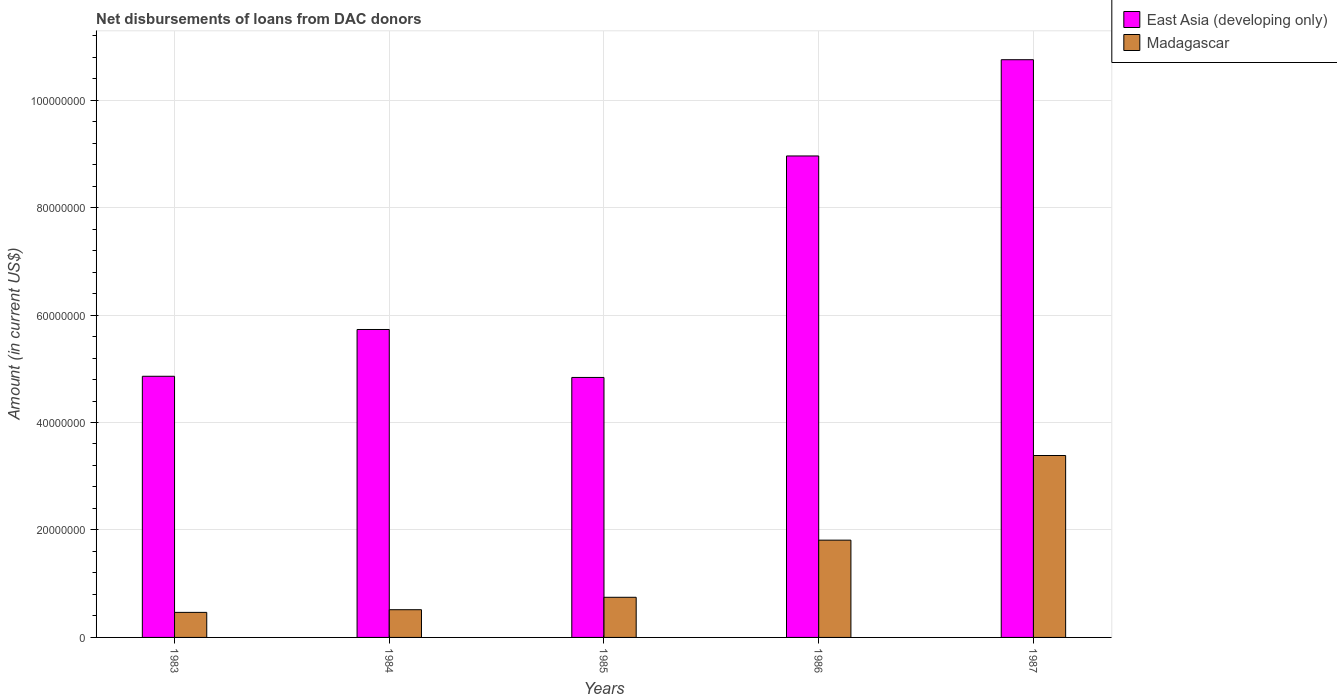How many groups of bars are there?
Provide a succinct answer. 5. Are the number of bars per tick equal to the number of legend labels?
Ensure brevity in your answer.  Yes. Are the number of bars on each tick of the X-axis equal?
Provide a succinct answer. Yes. What is the amount of loans disbursed in East Asia (developing only) in 1987?
Your answer should be very brief. 1.08e+08. Across all years, what is the maximum amount of loans disbursed in Madagascar?
Offer a very short reply. 3.39e+07. Across all years, what is the minimum amount of loans disbursed in East Asia (developing only)?
Your answer should be very brief. 4.84e+07. In which year was the amount of loans disbursed in East Asia (developing only) maximum?
Offer a terse response. 1987. What is the total amount of loans disbursed in Madagascar in the graph?
Your answer should be compact. 6.92e+07. What is the difference between the amount of loans disbursed in East Asia (developing only) in 1984 and that in 1985?
Give a very brief answer. 8.92e+06. What is the difference between the amount of loans disbursed in East Asia (developing only) in 1983 and the amount of loans disbursed in Madagascar in 1985?
Your answer should be very brief. 4.11e+07. What is the average amount of loans disbursed in Madagascar per year?
Offer a terse response. 1.38e+07. In the year 1986, what is the difference between the amount of loans disbursed in Madagascar and amount of loans disbursed in East Asia (developing only)?
Offer a very short reply. -7.15e+07. In how many years, is the amount of loans disbursed in East Asia (developing only) greater than 56000000 US$?
Keep it short and to the point. 3. What is the ratio of the amount of loans disbursed in Madagascar in 1983 to that in 1986?
Offer a terse response. 0.26. Is the amount of loans disbursed in Madagascar in 1983 less than that in 1986?
Your answer should be very brief. Yes. Is the difference between the amount of loans disbursed in Madagascar in 1983 and 1987 greater than the difference between the amount of loans disbursed in East Asia (developing only) in 1983 and 1987?
Make the answer very short. Yes. What is the difference between the highest and the second highest amount of loans disbursed in East Asia (developing only)?
Make the answer very short. 1.79e+07. What is the difference between the highest and the lowest amount of loans disbursed in East Asia (developing only)?
Your answer should be compact. 5.91e+07. What does the 2nd bar from the left in 1983 represents?
Offer a very short reply. Madagascar. What does the 1st bar from the right in 1987 represents?
Ensure brevity in your answer.  Madagascar. Does the graph contain any zero values?
Keep it short and to the point. No. Does the graph contain grids?
Give a very brief answer. Yes. How many legend labels are there?
Your response must be concise. 2. How are the legend labels stacked?
Offer a terse response. Vertical. What is the title of the graph?
Your response must be concise. Net disbursements of loans from DAC donors. What is the label or title of the X-axis?
Provide a short and direct response. Years. What is the label or title of the Y-axis?
Give a very brief answer. Amount (in current US$). What is the Amount (in current US$) in East Asia (developing only) in 1983?
Your answer should be very brief. 4.86e+07. What is the Amount (in current US$) of Madagascar in 1983?
Offer a very short reply. 4.66e+06. What is the Amount (in current US$) in East Asia (developing only) in 1984?
Your answer should be compact. 5.73e+07. What is the Amount (in current US$) in Madagascar in 1984?
Your answer should be very brief. 5.16e+06. What is the Amount (in current US$) in East Asia (developing only) in 1985?
Provide a succinct answer. 4.84e+07. What is the Amount (in current US$) in Madagascar in 1985?
Offer a very short reply. 7.47e+06. What is the Amount (in current US$) of East Asia (developing only) in 1986?
Your answer should be very brief. 8.96e+07. What is the Amount (in current US$) in Madagascar in 1986?
Give a very brief answer. 1.81e+07. What is the Amount (in current US$) of East Asia (developing only) in 1987?
Provide a short and direct response. 1.08e+08. What is the Amount (in current US$) of Madagascar in 1987?
Your answer should be very brief. 3.39e+07. Across all years, what is the maximum Amount (in current US$) of East Asia (developing only)?
Keep it short and to the point. 1.08e+08. Across all years, what is the maximum Amount (in current US$) of Madagascar?
Provide a succinct answer. 3.39e+07. Across all years, what is the minimum Amount (in current US$) of East Asia (developing only)?
Offer a terse response. 4.84e+07. Across all years, what is the minimum Amount (in current US$) in Madagascar?
Ensure brevity in your answer.  4.66e+06. What is the total Amount (in current US$) in East Asia (developing only) in the graph?
Make the answer very short. 3.51e+08. What is the total Amount (in current US$) of Madagascar in the graph?
Your answer should be very brief. 6.92e+07. What is the difference between the Amount (in current US$) in East Asia (developing only) in 1983 and that in 1984?
Ensure brevity in your answer.  -8.71e+06. What is the difference between the Amount (in current US$) in Madagascar in 1983 and that in 1984?
Give a very brief answer. -4.95e+05. What is the difference between the Amount (in current US$) of East Asia (developing only) in 1983 and that in 1985?
Ensure brevity in your answer.  2.18e+05. What is the difference between the Amount (in current US$) of Madagascar in 1983 and that in 1985?
Keep it short and to the point. -2.81e+06. What is the difference between the Amount (in current US$) in East Asia (developing only) in 1983 and that in 1986?
Offer a very short reply. -4.10e+07. What is the difference between the Amount (in current US$) of Madagascar in 1983 and that in 1986?
Ensure brevity in your answer.  -1.34e+07. What is the difference between the Amount (in current US$) in East Asia (developing only) in 1983 and that in 1987?
Your answer should be very brief. -5.89e+07. What is the difference between the Amount (in current US$) in Madagascar in 1983 and that in 1987?
Provide a succinct answer. -2.92e+07. What is the difference between the Amount (in current US$) in East Asia (developing only) in 1984 and that in 1985?
Ensure brevity in your answer.  8.92e+06. What is the difference between the Amount (in current US$) of Madagascar in 1984 and that in 1985?
Your response must be concise. -2.31e+06. What is the difference between the Amount (in current US$) of East Asia (developing only) in 1984 and that in 1986?
Your answer should be compact. -3.23e+07. What is the difference between the Amount (in current US$) in Madagascar in 1984 and that in 1986?
Give a very brief answer. -1.29e+07. What is the difference between the Amount (in current US$) of East Asia (developing only) in 1984 and that in 1987?
Give a very brief answer. -5.02e+07. What is the difference between the Amount (in current US$) in Madagascar in 1984 and that in 1987?
Your response must be concise. -2.87e+07. What is the difference between the Amount (in current US$) in East Asia (developing only) in 1985 and that in 1986?
Your response must be concise. -4.12e+07. What is the difference between the Amount (in current US$) of Madagascar in 1985 and that in 1986?
Provide a succinct answer. -1.06e+07. What is the difference between the Amount (in current US$) in East Asia (developing only) in 1985 and that in 1987?
Keep it short and to the point. -5.91e+07. What is the difference between the Amount (in current US$) of Madagascar in 1985 and that in 1987?
Keep it short and to the point. -2.64e+07. What is the difference between the Amount (in current US$) of East Asia (developing only) in 1986 and that in 1987?
Offer a very short reply. -1.79e+07. What is the difference between the Amount (in current US$) of Madagascar in 1986 and that in 1987?
Give a very brief answer. -1.58e+07. What is the difference between the Amount (in current US$) in East Asia (developing only) in 1983 and the Amount (in current US$) in Madagascar in 1984?
Your response must be concise. 4.34e+07. What is the difference between the Amount (in current US$) of East Asia (developing only) in 1983 and the Amount (in current US$) of Madagascar in 1985?
Ensure brevity in your answer.  4.11e+07. What is the difference between the Amount (in current US$) of East Asia (developing only) in 1983 and the Amount (in current US$) of Madagascar in 1986?
Give a very brief answer. 3.05e+07. What is the difference between the Amount (in current US$) of East Asia (developing only) in 1983 and the Amount (in current US$) of Madagascar in 1987?
Offer a very short reply. 1.47e+07. What is the difference between the Amount (in current US$) of East Asia (developing only) in 1984 and the Amount (in current US$) of Madagascar in 1985?
Offer a terse response. 4.98e+07. What is the difference between the Amount (in current US$) in East Asia (developing only) in 1984 and the Amount (in current US$) in Madagascar in 1986?
Give a very brief answer. 3.92e+07. What is the difference between the Amount (in current US$) in East Asia (developing only) in 1984 and the Amount (in current US$) in Madagascar in 1987?
Your answer should be compact. 2.35e+07. What is the difference between the Amount (in current US$) in East Asia (developing only) in 1985 and the Amount (in current US$) in Madagascar in 1986?
Provide a succinct answer. 3.03e+07. What is the difference between the Amount (in current US$) of East Asia (developing only) in 1985 and the Amount (in current US$) of Madagascar in 1987?
Ensure brevity in your answer.  1.45e+07. What is the difference between the Amount (in current US$) of East Asia (developing only) in 1986 and the Amount (in current US$) of Madagascar in 1987?
Your answer should be very brief. 5.58e+07. What is the average Amount (in current US$) of East Asia (developing only) per year?
Your answer should be compact. 7.03e+07. What is the average Amount (in current US$) in Madagascar per year?
Provide a succinct answer. 1.38e+07. In the year 1983, what is the difference between the Amount (in current US$) of East Asia (developing only) and Amount (in current US$) of Madagascar?
Offer a terse response. 4.39e+07. In the year 1984, what is the difference between the Amount (in current US$) in East Asia (developing only) and Amount (in current US$) in Madagascar?
Provide a short and direct response. 5.22e+07. In the year 1985, what is the difference between the Amount (in current US$) in East Asia (developing only) and Amount (in current US$) in Madagascar?
Give a very brief answer. 4.09e+07. In the year 1986, what is the difference between the Amount (in current US$) in East Asia (developing only) and Amount (in current US$) in Madagascar?
Offer a terse response. 7.15e+07. In the year 1987, what is the difference between the Amount (in current US$) of East Asia (developing only) and Amount (in current US$) of Madagascar?
Offer a very short reply. 7.37e+07. What is the ratio of the Amount (in current US$) of East Asia (developing only) in 1983 to that in 1984?
Your answer should be compact. 0.85. What is the ratio of the Amount (in current US$) of Madagascar in 1983 to that in 1984?
Provide a short and direct response. 0.9. What is the ratio of the Amount (in current US$) of Madagascar in 1983 to that in 1985?
Provide a succinct answer. 0.62. What is the ratio of the Amount (in current US$) of East Asia (developing only) in 1983 to that in 1986?
Offer a very short reply. 0.54. What is the ratio of the Amount (in current US$) in Madagascar in 1983 to that in 1986?
Offer a very short reply. 0.26. What is the ratio of the Amount (in current US$) of East Asia (developing only) in 1983 to that in 1987?
Give a very brief answer. 0.45. What is the ratio of the Amount (in current US$) in Madagascar in 1983 to that in 1987?
Keep it short and to the point. 0.14. What is the ratio of the Amount (in current US$) of East Asia (developing only) in 1984 to that in 1985?
Give a very brief answer. 1.18. What is the ratio of the Amount (in current US$) of Madagascar in 1984 to that in 1985?
Ensure brevity in your answer.  0.69. What is the ratio of the Amount (in current US$) of East Asia (developing only) in 1984 to that in 1986?
Ensure brevity in your answer.  0.64. What is the ratio of the Amount (in current US$) in Madagascar in 1984 to that in 1986?
Your response must be concise. 0.28. What is the ratio of the Amount (in current US$) in East Asia (developing only) in 1984 to that in 1987?
Offer a terse response. 0.53. What is the ratio of the Amount (in current US$) in Madagascar in 1984 to that in 1987?
Offer a very short reply. 0.15. What is the ratio of the Amount (in current US$) of East Asia (developing only) in 1985 to that in 1986?
Ensure brevity in your answer.  0.54. What is the ratio of the Amount (in current US$) in Madagascar in 1985 to that in 1986?
Give a very brief answer. 0.41. What is the ratio of the Amount (in current US$) of East Asia (developing only) in 1985 to that in 1987?
Provide a short and direct response. 0.45. What is the ratio of the Amount (in current US$) in Madagascar in 1985 to that in 1987?
Give a very brief answer. 0.22. What is the ratio of the Amount (in current US$) in East Asia (developing only) in 1986 to that in 1987?
Your answer should be very brief. 0.83. What is the ratio of the Amount (in current US$) of Madagascar in 1986 to that in 1987?
Offer a very short reply. 0.53. What is the difference between the highest and the second highest Amount (in current US$) in East Asia (developing only)?
Your response must be concise. 1.79e+07. What is the difference between the highest and the second highest Amount (in current US$) of Madagascar?
Make the answer very short. 1.58e+07. What is the difference between the highest and the lowest Amount (in current US$) in East Asia (developing only)?
Provide a short and direct response. 5.91e+07. What is the difference between the highest and the lowest Amount (in current US$) in Madagascar?
Make the answer very short. 2.92e+07. 